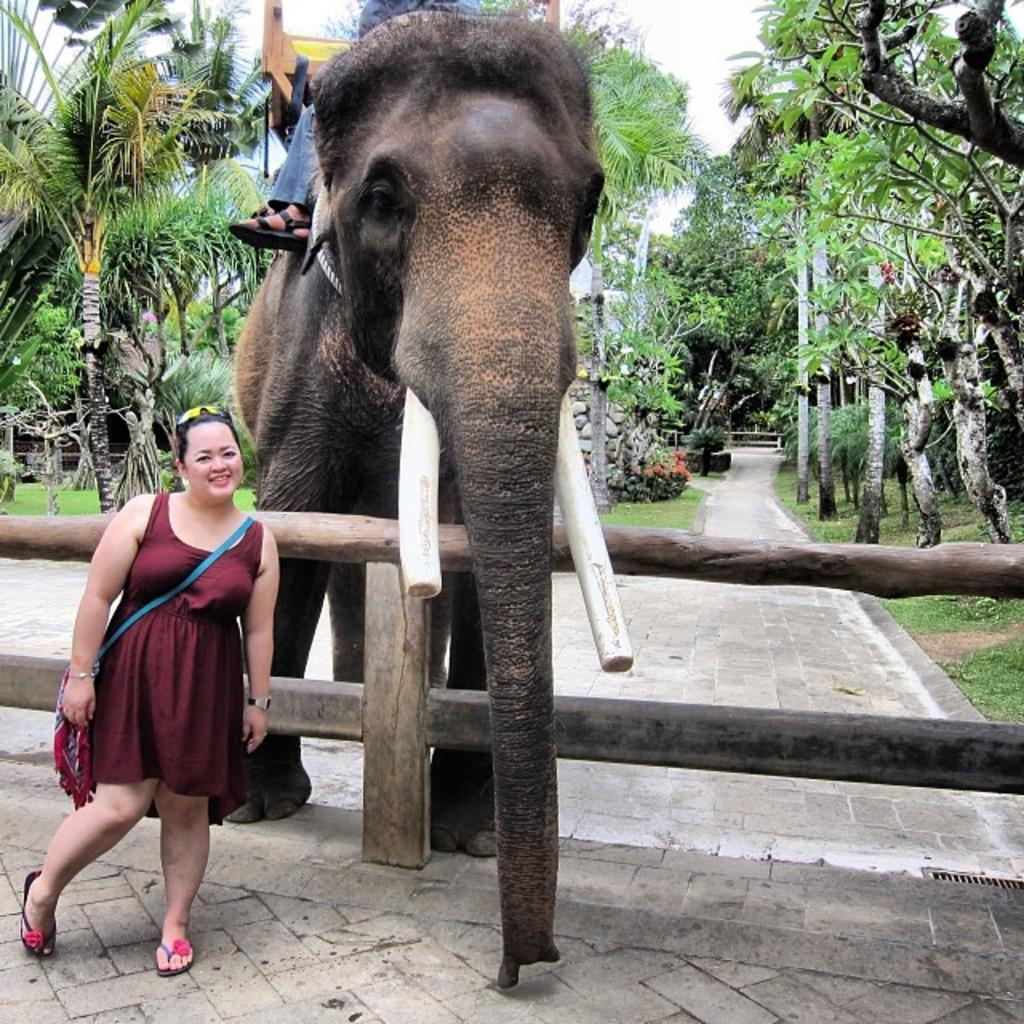Please provide a concise description of this image. In this picture I can see a human sitting on the elephant and I can see a woman standing, she is wearing a bag. I can see trees, few plants, a wooden fence and a cloudy sky. 